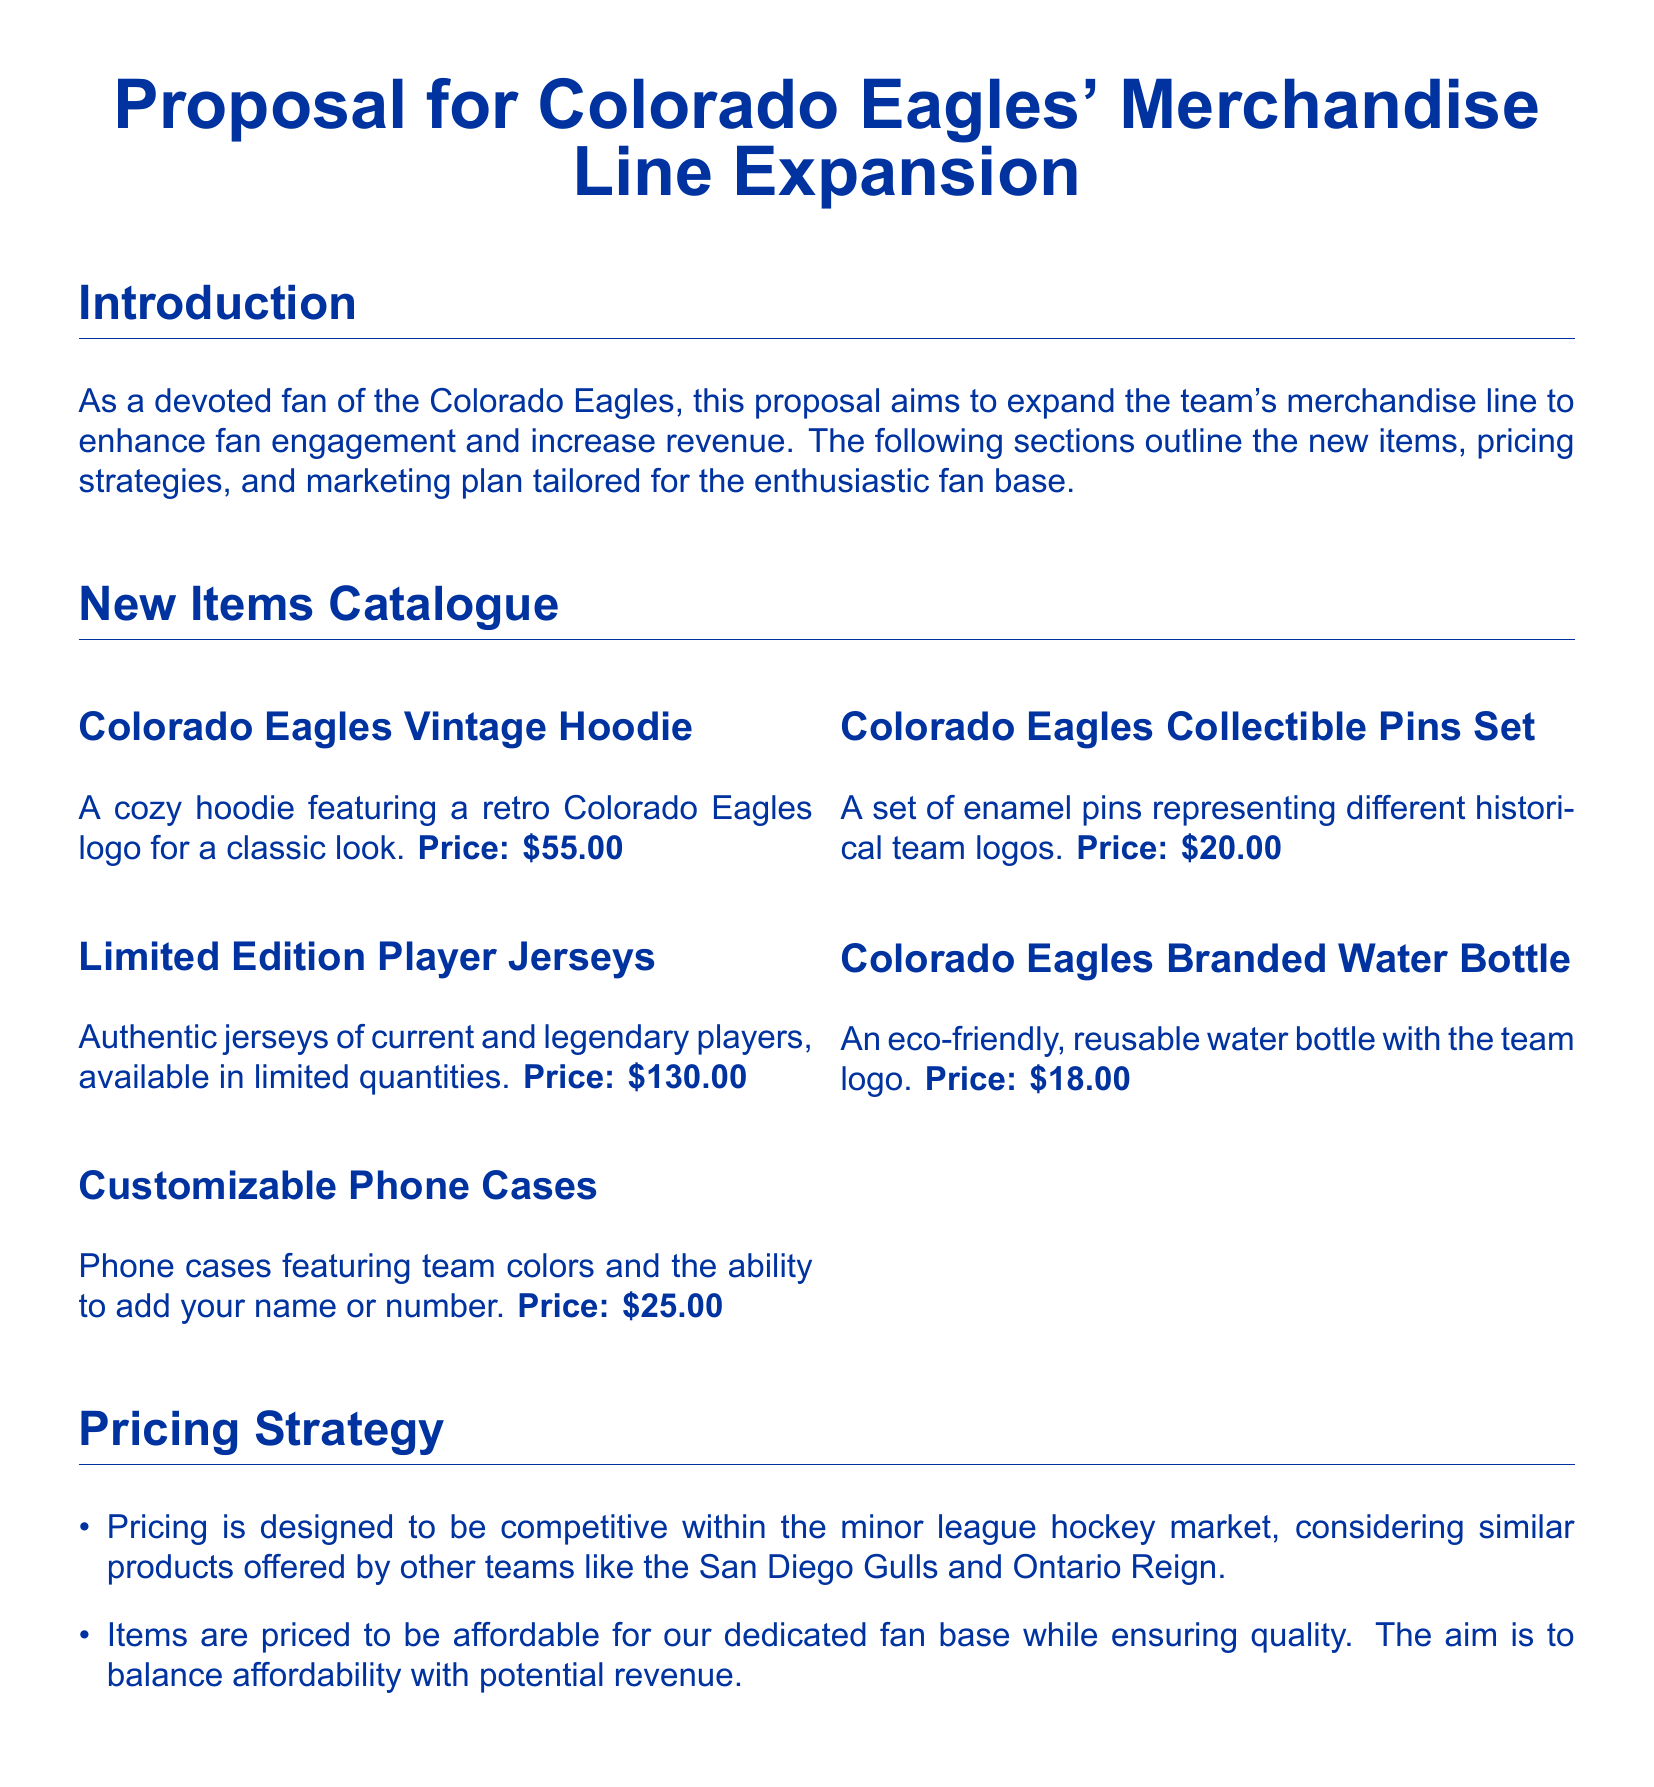What is the price of the Vintage Hoodie? The price is explicitly mentioned in the catalogue section of the document.
Answer: $55.00 What type of items are included in the new merchandise catalogue? The document lists specific categories of items under the New Items Catalogue section.
Answer: Hoodies, jerseys, phone cases, pins, water bottles How are the new items priced compared to other teams? The document describes the pricing strategy in relation to the minor league hockey market.
Answer: Competitive What is the price of the Limited Edition Player Jerseys? This specific price is provided in the catalogue of new items in the document.
Answer: $130.00 How often will the email newsletter be sent out? The document specifies the frequency of the newsletter in the marketing plan.
Answer: Bi-weekly What strategy is suggested to promote merchandise on game days? The document outlines promotional strategies for enhancing sales during game days.
Answer: Limited-time discounts Which social media platforms are mentioned for marketing? These details are included under the marketing plan section.
Answer: Facebook, Instagram, Twitter What is the purpose of the document? The document presents a proposal for merchandise expansion and outlines specific objectives.
Answer: Expand merchandise line What type of water bottle is being offered? The catalogue section provides specific details about the merchandise being offered, including descriptions.
Answer: Eco-friendly, reusable 